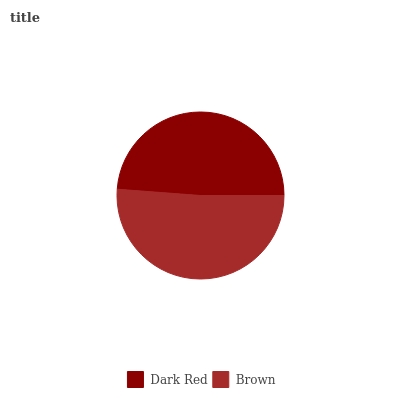Is Dark Red the minimum?
Answer yes or no. Yes. Is Brown the maximum?
Answer yes or no. Yes. Is Brown the minimum?
Answer yes or no. No. Is Brown greater than Dark Red?
Answer yes or no. Yes. Is Dark Red less than Brown?
Answer yes or no. Yes. Is Dark Red greater than Brown?
Answer yes or no. No. Is Brown less than Dark Red?
Answer yes or no. No. Is Brown the high median?
Answer yes or no. Yes. Is Dark Red the low median?
Answer yes or no. Yes. Is Dark Red the high median?
Answer yes or no. No. Is Brown the low median?
Answer yes or no. No. 